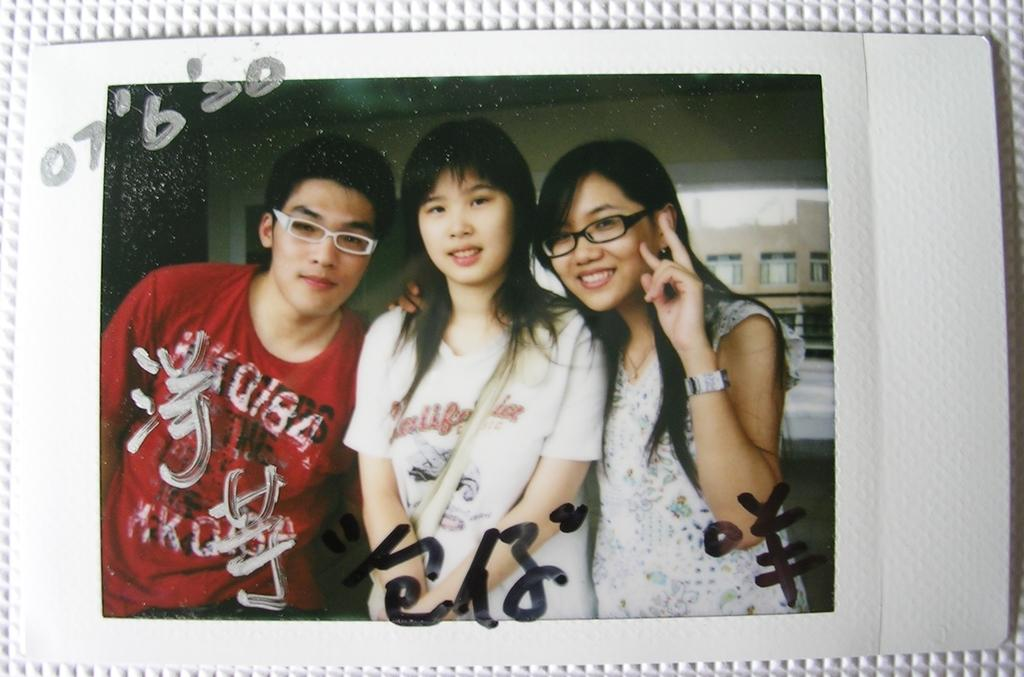What is the main subject in the center of the image? There is a photograph in the center of the image. What can be seen in the photograph? The photograph contains three people standing. What is visible in the background of the photograph? There are buildings in the background of the photograph. What type of cream can be seen dripping from the eye of one of the people in the photograph? There is no cream or dripping substance visible in the photograph, and no one's eye is mentioned in the provided facts. 